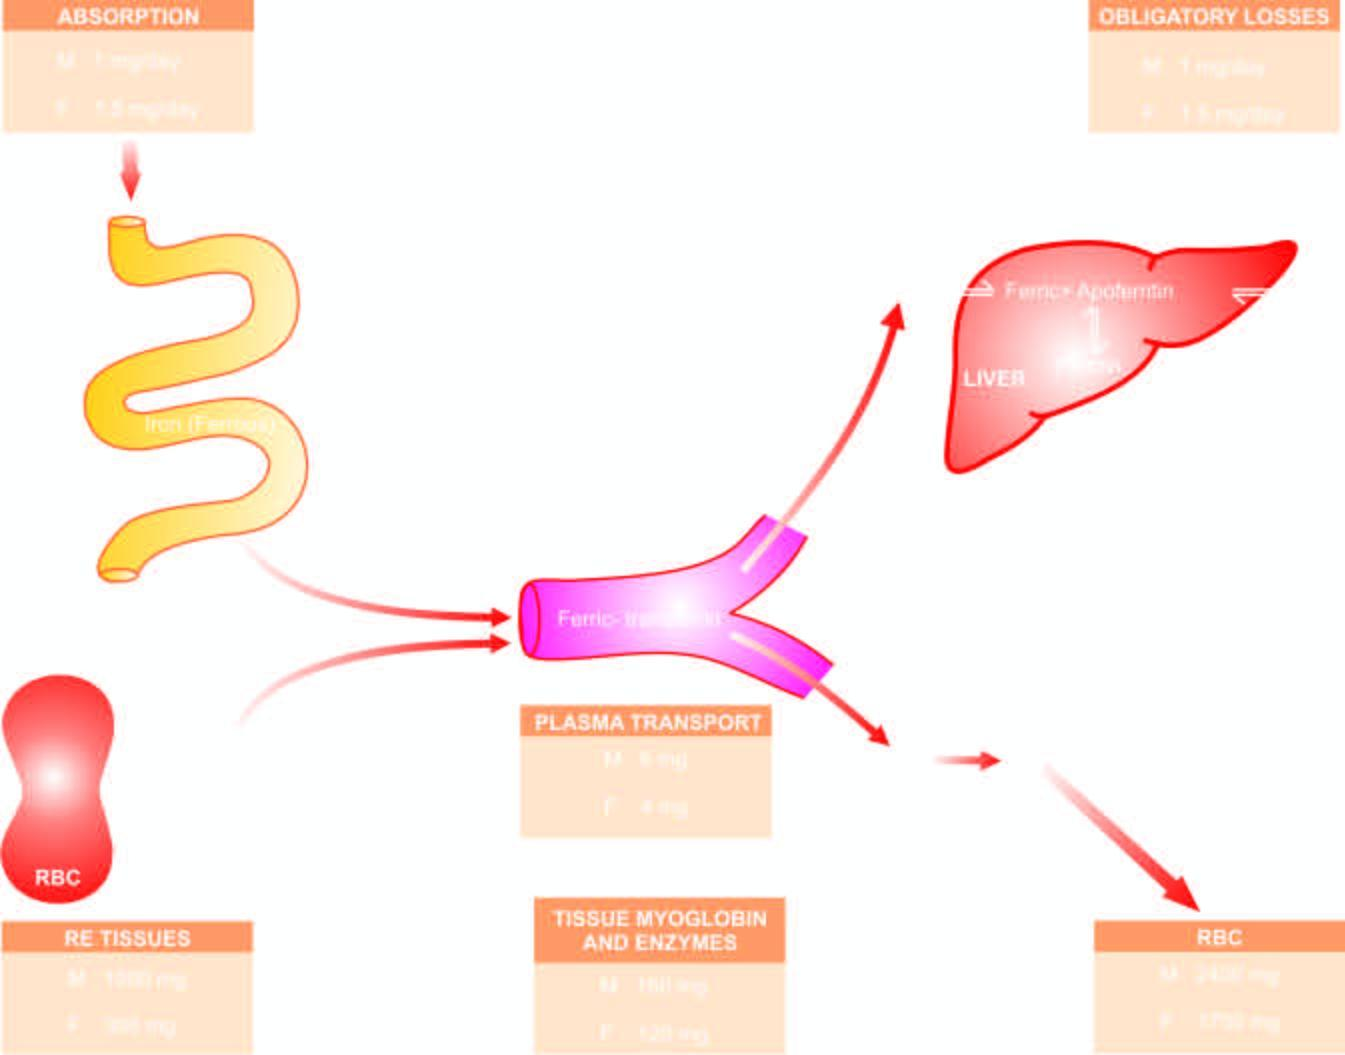does the cut surface circulate in plasma bound to transferrin and is transported to the bone marrow for utilisation in haemoglobin synthesis?
Answer the question using a single word or phrase. No 